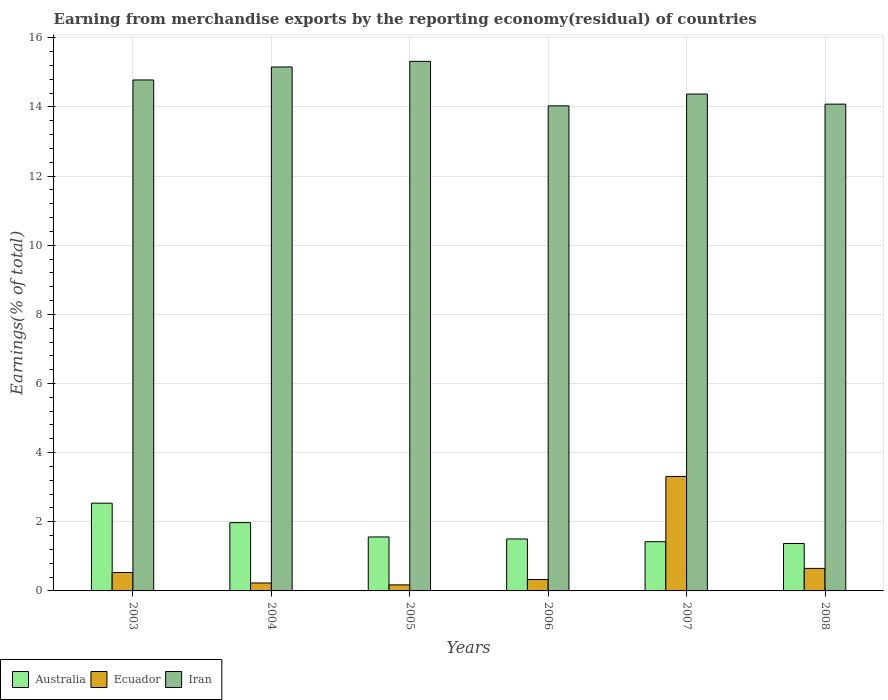How many different coloured bars are there?
Your answer should be compact. 3. How many groups of bars are there?
Provide a short and direct response. 6. Are the number of bars on each tick of the X-axis equal?
Offer a terse response. Yes. How many bars are there on the 3rd tick from the left?
Offer a very short reply. 3. What is the percentage of amount earned from merchandise exports in Ecuador in 2006?
Ensure brevity in your answer.  0.33. Across all years, what is the maximum percentage of amount earned from merchandise exports in Australia?
Offer a very short reply. 2.54. Across all years, what is the minimum percentage of amount earned from merchandise exports in Ecuador?
Your response must be concise. 0.17. In which year was the percentage of amount earned from merchandise exports in Iran maximum?
Your response must be concise. 2005. In which year was the percentage of amount earned from merchandise exports in Australia minimum?
Your answer should be compact. 2008. What is the total percentage of amount earned from merchandise exports in Australia in the graph?
Your answer should be compact. 10.37. What is the difference between the percentage of amount earned from merchandise exports in Australia in 2004 and that in 2008?
Make the answer very short. 0.6. What is the difference between the percentage of amount earned from merchandise exports in Iran in 2008 and the percentage of amount earned from merchandise exports in Australia in 2004?
Provide a succinct answer. 12.11. What is the average percentage of amount earned from merchandise exports in Australia per year?
Ensure brevity in your answer.  1.73. In the year 2003, what is the difference between the percentage of amount earned from merchandise exports in Iran and percentage of amount earned from merchandise exports in Ecuador?
Offer a very short reply. 14.25. In how many years, is the percentage of amount earned from merchandise exports in Iran greater than 9.6 %?
Your response must be concise. 6. What is the ratio of the percentage of amount earned from merchandise exports in Ecuador in 2003 to that in 2004?
Make the answer very short. 2.32. Is the difference between the percentage of amount earned from merchandise exports in Iran in 2003 and 2004 greater than the difference between the percentage of amount earned from merchandise exports in Ecuador in 2003 and 2004?
Ensure brevity in your answer.  No. What is the difference between the highest and the second highest percentage of amount earned from merchandise exports in Iran?
Give a very brief answer. 0.16. What is the difference between the highest and the lowest percentage of amount earned from merchandise exports in Ecuador?
Ensure brevity in your answer.  3.14. Is the sum of the percentage of amount earned from merchandise exports in Australia in 2003 and 2005 greater than the maximum percentage of amount earned from merchandise exports in Iran across all years?
Your answer should be very brief. No. What does the 2nd bar from the left in 2004 represents?
Keep it short and to the point. Ecuador. What does the 2nd bar from the right in 2005 represents?
Your answer should be compact. Ecuador. Is it the case that in every year, the sum of the percentage of amount earned from merchandise exports in Ecuador and percentage of amount earned from merchandise exports in Iran is greater than the percentage of amount earned from merchandise exports in Australia?
Make the answer very short. Yes. How many bars are there?
Your answer should be compact. 18. Are all the bars in the graph horizontal?
Keep it short and to the point. No. How many years are there in the graph?
Ensure brevity in your answer.  6. What is the difference between two consecutive major ticks on the Y-axis?
Make the answer very short. 2. Are the values on the major ticks of Y-axis written in scientific E-notation?
Keep it short and to the point. No. Does the graph contain any zero values?
Your answer should be compact. No. Does the graph contain grids?
Your answer should be compact. Yes. How many legend labels are there?
Provide a succinct answer. 3. How are the legend labels stacked?
Ensure brevity in your answer.  Horizontal. What is the title of the graph?
Provide a succinct answer. Earning from merchandise exports by the reporting economy(residual) of countries. Does "Albania" appear as one of the legend labels in the graph?
Offer a very short reply. No. What is the label or title of the Y-axis?
Your answer should be compact. Earnings(% of total). What is the Earnings(% of total) of Australia in 2003?
Make the answer very short. 2.54. What is the Earnings(% of total) of Ecuador in 2003?
Make the answer very short. 0.53. What is the Earnings(% of total) of Iran in 2003?
Give a very brief answer. 14.78. What is the Earnings(% of total) of Australia in 2004?
Give a very brief answer. 1.97. What is the Earnings(% of total) of Ecuador in 2004?
Your answer should be very brief. 0.23. What is the Earnings(% of total) in Iran in 2004?
Provide a short and direct response. 15.16. What is the Earnings(% of total) of Australia in 2005?
Ensure brevity in your answer.  1.56. What is the Earnings(% of total) of Ecuador in 2005?
Ensure brevity in your answer.  0.17. What is the Earnings(% of total) of Iran in 2005?
Make the answer very short. 15.32. What is the Earnings(% of total) in Australia in 2006?
Offer a terse response. 1.5. What is the Earnings(% of total) of Ecuador in 2006?
Your response must be concise. 0.33. What is the Earnings(% of total) of Iran in 2006?
Keep it short and to the point. 14.03. What is the Earnings(% of total) of Australia in 2007?
Offer a very short reply. 1.42. What is the Earnings(% of total) of Ecuador in 2007?
Make the answer very short. 3.31. What is the Earnings(% of total) of Iran in 2007?
Provide a succinct answer. 14.37. What is the Earnings(% of total) in Australia in 2008?
Your response must be concise. 1.37. What is the Earnings(% of total) in Ecuador in 2008?
Your response must be concise. 0.65. What is the Earnings(% of total) of Iran in 2008?
Offer a terse response. 14.08. Across all years, what is the maximum Earnings(% of total) of Australia?
Make the answer very short. 2.54. Across all years, what is the maximum Earnings(% of total) in Ecuador?
Your response must be concise. 3.31. Across all years, what is the maximum Earnings(% of total) in Iran?
Your answer should be very brief. 15.32. Across all years, what is the minimum Earnings(% of total) in Australia?
Give a very brief answer. 1.37. Across all years, what is the minimum Earnings(% of total) in Ecuador?
Keep it short and to the point. 0.17. Across all years, what is the minimum Earnings(% of total) in Iran?
Make the answer very short. 14.03. What is the total Earnings(% of total) of Australia in the graph?
Your answer should be compact. 10.37. What is the total Earnings(% of total) of Ecuador in the graph?
Provide a short and direct response. 5.23. What is the total Earnings(% of total) in Iran in the graph?
Your response must be concise. 87.74. What is the difference between the Earnings(% of total) in Australia in 2003 and that in 2004?
Make the answer very short. 0.56. What is the difference between the Earnings(% of total) of Ecuador in 2003 and that in 2004?
Your response must be concise. 0.3. What is the difference between the Earnings(% of total) of Iran in 2003 and that in 2004?
Provide a succinct answer. -0.38. What is the difference between the Earnings(% of total) of Ecuador in 2003 and that in 2005?
Keep it short and to the point. 0.36. What is the difference between the Earnings(% of total) of Iran in 2003 and that in 2005?
Keep it short and to the point. -0.54. What is the difference between the Earnings(% of total) of Australia in 2003 and that in 2006?
Provide a short and direct response. 1.04. What is the difference between the Earnings(% of total) in Ecuador in 2003 and that in 2006?
Provide a short and direct response. 0.2. What is the difference between the Earnings(% of total) in Iran in 2003 and that in 2006?
Your response must be concise. 0.75. What is the difference between the Earnings(% of total) in Australia in 2003 and that in 2007?
Offer a terse response. 1.11. What is the difference between the Earnings(% of total) in Ecuador in 2003 and that in 2007?
Offer a terse response. -2.78. What is the difference between the Earnings(% of total) of Iran in 2003 and that in 2007?
Your answer should be very brief. 0.41. What is the difference between the Earnings(% of total) of Australia in 2003 and that in 2008?
Offer a very short reply. 1.17. What is the difference between the Earnings(% of total) in Ecuador in 2003 and that in 2008?
Provide a short and direct response. -0.12. What is the difference between the Earnings(% of total) in Iran in 2003 and that in 2008?
Offer a terse response. 0.7. What is the difference between the Earnings(% of total) in Australia in 2004 and that in 2005?
Keep it short and to the point. 0.41. What is the difference between the Earnings(% of total) in Ecuador in 2004 and that in 2005?
Provide a succinct answer. 0.06. What is the difference between the Earnings(% of total) in Iran in 2004 and that in 2005?
Your response must be concise. -0.16. What is the difference between the Earnings(% of total) of Australia in 2004 and that in 2006?
Keep it short and to the point. 0.47. What is the difference between the Earnings(% of total) of Ecuador in 2004 and that in 2006?
Provide a short and direct response. -0.1. What is the difference between the Earnings(% of total) of Iran in 2004 and that in 2006?
Ensure brevity in your answer.  1.12. What is the difference between the Earnings(% of total) in Australia in 2004 and that in 2007?
Offer a terse response. 0.55. What is the difference between the Earnings(% of total) in Ecuador in 2004 and that in 2007?
Provide a short and direct response. -3.08. What is the difference between the Earnings(% of total) in Iran in 2004 and that in 2007?
Make the answer very short. 0.78. What is the difference between the Earnings(% of total) of Australia in 2004 and that in 2008?
Offer a very short reply. 0.6. What is the difference between the Earnings(% of total) in Ecuador in 2004 and that in 2008?
Keep it short and to the point. -0.42. What is the difference between the Earnings(% of total) of Iran in 2004 and that in 2008?
Offer a terse response. 1.07. What is the difference between the Earnings(% of total) in Australia in 2005 and that in 2006?
Your response must be concise. 0.06. What is the difference between the Earnings(% of total) of Ecuador in 2005 and that in 2006?
Your response must be concise. -0.16. What is the difference between the Earnings(% of total) of Iran in 2005 and that in 2006?
Offer a terse response. 1.29. What is the difference between the Earnings(% of total) in Australia in 2005 and that in 2007?
Provide a short and direct response. 0.14. What is the difference between the Earnings(% of total) in Ecuador in 2005 and that in 2007?
Offer a very short reply. -3.14. What is the difference between the Earnings(% of total) of Iran in 2005 and that in 2007?
Give a very brief answer. 0.95. What is the difference between the Earnings(% of total) in Australia in 2005 and that in 2008?
Offer a very short reply. 0.19. What is the difference between the Earnings(% of total) of Ecuador in 2005 and that in 2008?
Provide a succinct answer. -0.48. What is the difference between the Earnings(% of total) in Iran in 2005 and that in 2008?
Offer a very short reply. 1.24. What is the difference between the Earnings(% of total) of Australia in 2006 and that in 2007?
Provide a short and direct response. 0.08. What is the difference between the Earnings(% of total) of Ecuador in 2006 and that in 2007?
Provide a succinct answer. -2.98. What is the difference between the Earnings(% of total) of Iran in 2006 and that in 2007?
Ensure brevity in your answer.  -0.34. What is the difference between the Earnings(% of total) in Australia in 2006 and that in 2008?
Your answer should be very brief. 0.13. What is the difference between the Earnings(% of total) of Ecuador in 2006 and that in 2008?
Give a very brief answer. -0.32. What is the difference between the Earnings(% of total) of Iran in 2006 and that in 2008?
Your response must be concise. -0.05. What is the difference between the Earnings(% of total) of Australia in 2007 and that in 2008?
Offer a very short reply. 0.05. What is the difference between the Earnings(% of total) in Ecuador in 2007 and that in 2008?
Keep it short and to the point. 2.66. What is the difference between the Earnings(% of total) of Iran in 2007 and that in 2008?
Ensure brevity in your answer.  0.29. What is the difference between the Earnings(% of total) in Australia in 2003 and the Earnings(% of total) in Ecuador in 2004?
Provide a short and direct response. 2.31. What is the difference between the Earnings(% of total) of Australia in 2003 and the Earnings(% of total) of Iran in 2004?
Make the answer very short. -12.62. What is the difference between the Earnings(% of total) in Ecuador in 2003 and the Earnings(% of total) in Iran in 2004?
Give a very brief answer. -14.62. What is the difference between the Earnings(% of total) in Australia in 2003 and the Earnings(% of total) in Ecuador in 2005?
Your answer should be compact. 2.36. What is the difference between the Earnings(% of total) in Australia in 2003 and the Earnings(% of total) in Iran in 2005?
Your answer should be very brief. -12.78. What is the difference between the Earnings(% of total) in Ecuador in 2003 and the Earnings(% of total) in Iran in 2005?
Make the answer very short. -14.78. What is the difference between the Earnings(% of total) of Australia in 2003 and the Earnings(% of total) of Ecuador in 2006?
Your answer should be very brief. 2.21. What is the difference between the Earnings(% of total) of Australia in 2003 and the Earnings(% of total) of Iran in 2006?
Ensure brevity in your answer.  -11.49. What is the difference between the Earnings(% of total) in Ecuador in 2003 and the Earnings(% of total) in Iran in 2006?
Your answer should be compact. -13.5. What is the difference between the Earnings(% of total) of Australia in 2003 and the Earnings(% of total) of Ecuador in 2007?
Offer a terse response. -0.77. What is the difference between the Earnings(% of total) of Australia in 2003 and the Earnings(% of total) of Iran in 2007?
Make the answer very short. -11.83. What is the difference between the Earnings(% of total) in Ecuador in 2003 and the Earnings(% of total) in Iran in 2007?
Keep it short and to the point. -13.84. What is the difference between the Earnings(% of total) in Australia in 2003 and the Earnings(% of total) in Ecuador in 2008?
Offer a terse response. 1.89. What is the difference between the Earnings(% of total) in Australia in 2003 and the Earnings(% of total) in Iran in 2008?
Ensure brevity in your answer.  -11.54. What is the difference between the Earnings(% of total) of Ecuador in 2003 and the Earnings(% of total) of Iran in 2008?
Ensure brevity in your answer.  -13.55. What is the difference between the Earnings(% of total) of Australia in 2004 and the Earnings(% of total) of Ecuador in 2005?
Keep it short and to the point. 1.8. What is the difference between the Earnings(% of total) in Australia in 2004 and the Earnings(% of total) in Iran in 2005?
Provide a succinct answer. -13.34. What is the difference between the Earnings(% of total) in Ecuador in 2004 and the Earnings(% of total) in Iran in 2005?
Your answer should be very brief. -15.09. What is the difference between the Earnings(% of total) in Australia in 2004 and the Earnings(% of total) in Ecuador in 2006?
Provide a short and direct response. 1.64. What is the difference between the Earnings(% of total) of Australia in 2004 and the Earnings(% of total) of Iran in 2006?
Offer a very short reply. -12.06. What is the difference between the Earnings(% of total) in Ecuador in 2004 and the Earnings(% of total) in Iran in 2006?
Offer a terse response. -13.8. What is the difference between the Earnings(% of total) of Australia in 2004 and the Earnings(% of total) of Ecuador in 2007?
Ensure brevity in your answer.  -1.34. What is the difference between the Earnings(% of total) in Australia in 2004 and the Earnings(% of total) in Iran in 2007?
Offer a terse response. -12.4. What is the difference between the Earnings(% of total) of Ecuador in 2004 and the Earnings(% of total) of Iran in 2007?
Your response must be concise. -14.14. What is the difference between the Earnings(% of total) in Australia in 2004 and the Earnings(% of total) in Ecuador in 2008?
Keep it short and to the point. 1.32. What is the difference between the Earnings(% of total) of Australia in 2004 and the Earnings(% of total) of Iran in 2008?
Your answer should be compact. -12.11. What is the difference between the Earnings(% of total) in Ecuador in 2004 and the Earnings(% of total) in Iran in 2008?
Provide a short and direct response. -13.85. What is the difference between the Earnings(% of total) in Australia in 2005 and the Earnings(% of total) in Ecuador in 2006?
Your answer should be compact. 1.23. What is the difference between the Earnings(% of total) in Australia in 2005 and the Earnings(% of total) in Iran in 2006?
Provide a short and direct response. -12.47. What is the difference between the Earnings(% of total) in Ecuador in 2005 and the Earnings(% of total) in Iran in 2006?
Keep it short and to the point. -13.86. What is the difference between the Earnings(% of total) of Australia in 2005 and the Earnings(% of total) of Ecuador in 2007?
Keep it short and to the point. -1.75. What is the difference between the Earnings(% of total) in Australia in 2005 and the Earnings(% of total) in Iran in 2007?
Your answer should be very brief. -12.81. What is the difference between the Earnings(% of total) of Ecuador in 2005 and the Earnings(% of total) of Iran in 2007?
Your answer should be very brief. -14.2. What is the difference between the Earnings(% of total) in Australia in 2005 and the Earnings(% of total) in Ecuador in 2008?
Offer a very short reply. 0.91. What is the difference between the Earnings(% of total) of Australia in 2005 and the Earnings(% of total) of Iran in 2008?
Keep it short and to the point. -12.52. What is the difference between the Earnings(% of total) in Ecuador in 2005 and the Earnings(% of total) in Iran in 2008?
Give a very brief answer. -13.91. What is the difference between the Earnings(% of total) of Australia in 2006 and the Earnings(% of total) of Ecuador in 2007?
Offer a very short reply. -1.81. What is the difference between the Earnings(% of total) in Australia in 2006 and the Earnings(% of total) in Iran in 2007?
Your response must be concise. -12.87. What is the difference between the Earnings(% of total) in Ecuador in 2006 and the Earnings(% of total) in Iran in 2007?
Ensure brevity in your answer.  -14.04. What is the difference between the Earnings(% of total) of Australia in 2006 and the Earnings(% of total) of Ecuador in 2008?
Your response must be concise. 0.85. What is the difference between the Earnings(% of total) in Australia in 2006 and the Earnings(% of total) in Iran in 2008?
Your answer should be compact. -12.58. What is the difference between the Earnings(% of total) in Ecuador in 2006 and the Earnings(% of total) in Iran in 2008?
Ensure brevity in your answer.  -13.75. What is the difference between the Earnings(% of total) of Australia in 2007 and the Earnings(% of total) of Ecuador in 2008?
Offer a very short reply. 0.77. What is the difference between the Earnings(% of total) in Australia in 2007 and the Earnings(% of total) in Iran in 2008?
Your response must be concise. -12.66. What is the difference between the Earnings(% of total) in Ecuador in 2007 and the Earnings(% of total) in Iran in 2008?
Offer a terse response. -10.77. What is the average Earnings(% of total) in Australia per year?
Your response must be concise. 1.73. What is the average Earnings(% of total) in Ecuador per year?
Keep it short and to the point. 0.87. What is the average Earnings(% of total) of Iran per year?
Keep it short and to the point. 14.62. In the year 2003, what is the difference between the Earnings(% of total) of Australia and Earnings(% of total) of Ecuador?
Your response must be concise. 2. In the year 2003, what is the difference between the Earnings(% of total) of Australia and Earnings(% of total) of Iran?
Your answer should be very brief. -12.24. In the year 2003, what is the difference between the Earnings(% of total) of Ecuador and Earnings(% of total) of Iran?
Ensure brevity in your answer.  -14.25. In the year 2004, what is the difference between the Earnings(% of total) in Australia and Earnings(% of total) in Ecuador?
Ensure brevity in your answer.  1.74. In the year 2004, what is the difference between the Earnings(% of total) of Australia and Earnings(% of total) of Iran?
Your answer should be compact. -13.18. In the year 2004, what is the difference between the Earnings(% of total) of Ecuador and Earnings(% of total) of Iran?
Offer a terse response. -14.93. In the year 2005, what is the difference between the Earnings(% of total) in Australia and Earnings(% of total) in Ecuador?
Make the answer very short. 1.39. In the year 2005, what is the difference between the Earnings(% of total) of Australia and Earnings(% of total) of Iran?
Your response must be concise. -13.76. In the year 2005, what is the difference between the Earnings(% of total) in Ecuador and Earnings(% of total) in Iran?
Ensure brevity in your answer.  -15.14. In the year 2006, what is the difference between the Earnings(% of total) of Australia and Earnings(% of total) of Ecuador?
Your answer should be very brief. 1.17. In the year 2006, what is the difference between the Earnings(% of total) in Australia and Earnings(% of total) in Iran?
Make the answer very short. -12.53. In the year 2006, what is the difference between the Earnings(% of total) in Ecuador and Earnings(% of total) in Iran?
Offer a very short reply. -13.7. In the year 2007, what is the difference between the Earnings(% of total) of Australia and Earnings(% of total) of Ecuador?
Keep it short and to the point. -1.89. In the year 2007, what is the difference between the Earnings(% of total) of Australia and Earnings(% of total) of Iran?
Offer a very short reply. -12.95. In the year 2007, what is the difference between the Earnings(% of total) in Ecuador and Earnings(% of total) in Iran?
Keep it short and to the point. -11.06. In the year 2008, what is the difference between the Earnings(% of total) in Australia and Earnings(% of total) in Ecuador?
Your answer should be very brief. 0.72. In the year 2008, what is the difference between the Earnings(% of total) of Australia and Earnings(% of total) of Iran?
Provide a short and direct response. -12.71. In the year 2008, what is the difference between the Earnings(% of total) in Ecuador and Earnings(% of total) in Iran?
Offer a terse response. -13.43. What is the ratio of the Earnings(% of total) in Australia in 2003 to that in 2004?
Offer a terse response. 1.29. What is the ratio of the Earnings(% of total) of Ecuador in 2003 to that in 2004?
Make the answer very short. 2.32. What is the ratio of the Earnings(% of total) in Iran in 2003 to that in 2004?
Keep it short and to the point. 0.98. What is the ratio of the Earnings(% of total) in Australia in 2003 to that in 2005?
Give a very brief answer. 1.63. What is the ratio of the Earnings(% of total) of Ecuador in 2003 to that in 2005?
Provide a short and direct response. 3.06. What is the ratio of the Earnings(% of total) of Iran in 2003 to that in 2005?
Ensure brevity in your answer.  0.96. What is the ratio of the Earnings(% of total) in Australia in 2003 to that in 2006?
Your answer should be compact. 1.69. What is the ratio of the Earnings(% of total) in Ecuador in 2003 to that in 2006?
Provide a succinct answer. 1.62. What is the ratio of the Earnings(% of total) of Iran in 2003 to that in 2006?
Offer a terse response. 1.05. What is the ratio of the Earnings(% of total) in Australia in 2003 to that in 2007?
Your answer should be compact. 1.78. What is the ratio of the Earnings(% of total) in Ecuador in 2003 to that in 2007?
Offer a very short reply. 0.16. What is the ratio of the Earnings(% of total) in Iran in 2003 to that in 2007?
Give a very brief answer. 1.03. What is the ratio of the Earnings(% of total) of Australia in 2003 to that in 2008?
Your response must be concise. 1.85. What is the ratio of the Earnings(% of total) in Ecuador in 2003 to that in 2008?
Offer a terse response. 0.82. What is the ratio of the Earnings(% of total) of Iran in 2003 to that in 2008?
Make the answer very short. 1.05. What is the ratio of the Earnings(% of total) in Australia in 2004 to that in 2005?
Your response must be concise. 1.26. What is the ratio of the Earnings(% of total) in Ecuador in 2004 to that in 2005?
Provide a succinct answer. 1.32. What is the ratio of the Earnings(% of total) of Australia in 2004 to that in 2006?
Your answer should be very brief. 1.31. What is the ratio of the Earnings(% of total) of Ecuador in 2004 to that in 2006?
Provide a succinct answer. 0.7. What is the ratio of the Earnings(% of total) in Iran in 2004 to that in 2006?
Offer a terse response. 1.08. What is the ratio of the Earnings(% of total) in Australia in 2004 to that in 2007?
Keep it short and to the point. 1.39. What is the ratio of the Earnings(% of total) of Ecuador in 2004 to that in 2007?
Keep it short and to the point. 0.07. What is the ratio of the Earnings(% of total) in Iran in 2004 to that in 2007?
Make the answer very short. 1.05. What is the ratio of the Earnings(% of total) in Australia in 2004 to that in 2008?
Give a very brief answer. 1.44. What is the ratio of the Earnings(% of total) in Ecuador in 2004 to that in 2008?
Offer a very short reply. 0.35. What is the ratio of the Earnings(% of total) in Iran in 2004 to that in 2008?
Provide a short and direct response. 1.08. What is the ratio of the Earnings(% of total) of Australia in 2005 to that in 2006?
Make the answer very short. 1.04. What is the ratio of the Earnings(% of total) of Ecuador in 2005 to that in 2006?
Ensure brevity in your answer.  0.53. What is the ratio of the Earnings(% of total) of Iran in 2005 to that in 2006?
Make the answer very short. 1.09. What is the ratio of the Earnings(% of total) in Australia in 2005 to that in 2007?
Offer a terse response. 1.1. What is the ratio of the Earnings(% of total) of Ecuador in 2005 to that in 2007?
Make the answer very short. 0.05. What is the ratio of the Earnings(% of total) of Iran in 2005 to that in 2007?
Your response must be concise. 1.07. What is the ratio of the Earnings(% of total) of Australia in 2005 to that in 2008?
Ensure brevity in your answer.  1.14. What is the ratio of the Earnings(% of total) of Ecuador in 2005 to that in 2008?
Provide a short and direct response. 0.27. What is the ratio of the Earnings(% of total) in Iran in 2005 to that in 2008?
Provide a short and direct response. 1.09. What is the ratio of the Earnings(% of total) in Australia in 2006 to that in 2007?
Your answer should be compact. 1.06. What is the ratio of the Earnings(% of total) in Ecuador in 2006 to that in 2007?
Give a very brief answer. 0.1. What is the ratio of the Earnings(% of total) of Iran in 2006 to that in 2007?
Provide a succinct answer. 0.98. What is the ratio of the Earnings(% of total) in Australia in 2006 to that in 2008?
Offer a very short reply. 1.1. What is the ratio of the Earnings(% of total) in Ecuador in 2006 to that in 2008?
Your answer should be compact. 0.51. What is the ratio of the Earnings(% of total) in Australia in 2007 to that in 2008?
Your answer should be very brief. 1.04. What is the ratio of the Earnings(% of total) in Ecuador in 2007 to that in 2008?
Your answer should be very brief. 5.08. What is the ratio of the Earnings(% of total) in Iran in 2007 to that in 2008?
Provide a succinct answer. 1.02. What is the difference between the highest and the second highest Earnings(% of total) in Australia?
Give a very brief answer. 0.56. What is the difference between the highest and the second highest Earnings(% of total) in Ecuador?
Your answer should be very brief. 2.66. What is the difference between the highest and the second highest Earnings(% of total) in Iran?
Your response must be concise. 0.16. What is the difference between the highest and the lowest Earnings(% of total) of Australia?
Provide a short and direct response. 1.17. What is the difference between the highest and the lowest Earnings(% of total) in Ecuador?
Ensure brevity in your answer.  3.14. What is the difference between the highest and the lowest Earnings(% of total) of Iran?
Keep it short and to the point. 1.29. 